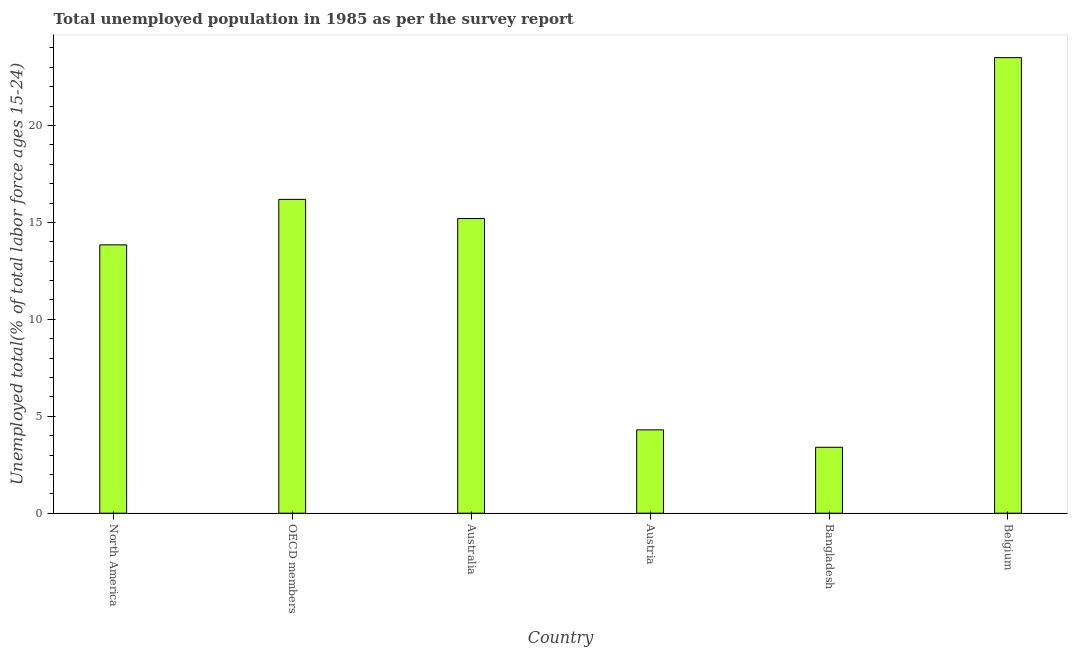Does the graph contain any zero values?
Provide a succinct answer. No. Does the graph contain grids?
Keep it short and to the point. No. What is the title of the graph?
Your answer should be very brief. Total unemployed population in 1985 as per the survey report. What is the label or title of the X-axis?
Your response must be concise. Country. What is the label or title of the Y-axis?
Your answer should be very brief. Unemployed total(% of total labor force ages 15-24). What is the unemployed youth in Bangladesh?
Offer a terse response. 3.4. Across all countries, what is the maximum unemployed youth?
Keep it short and to the point. 23.5. Across all countries, what is the minimum unemployed youth?
Your answer should be very brief. 3.4. In which country was the unemployed youth maximum?
Make the answer very short. Belgium. What is the sum of the unemployed youth?
Give a very brief answer. 76.43. What is the difference between the unemployed youth in Austria and Belgium?
Provide a short and direct response. -19.2. What is the average unemployed youth per country?
Keep it short and to the point. 12.74. What is the median unemployed youth?
Provide a short and direct response. 14.52. In how many countries, is the unemployed youth greater than 4 %?
Your response must be concise. 5. What is the ratio of the unemployed youth in Australia to that in Belgium?
Keep it short and to the point. 0.65. Is the unemployed youth in Austria less than that in OECD members?
Offer a very short reply. Yes. What is the difference between the highest and the second highest unemployed youth?
Provide a short and direct response. 7.31. What is the difference between the highest and the lowest unemployed youth?
Your answer should be compact. 20.1. In how many countries, is the unemployed youth greater than the average unemployed youth taken over all countries?
Your answer should be very brief. 4. How many bars are there?
Your answer should be very brief. 6. Are all the bars in the graph horizontal?
Provide a short and direct response. No. What is the difference between two consecutive major ticks on the Y-axis?
Make the answer very short. 5. What is the Unemployed total(% of total labor force ages 15-24) in North America?
Ensure brevity in your answer.  13.84. What is the Unemployed total(% of total labor force ages 15-24) in OECD members?
Your answer should be compact. 16.19. What is the Unemployed total(% of total labor force ages 15-24) of Australia?
Offer a very short reply. 15.2. What is the Unemployed total(% of total labor force ages 15-24) of Austria?
Offer a very short reply. 4.3. What is the Unemployed total(% of total labor force ages 15-24) of Bangladesh?
Give a very brief answer. 3.4. What is the difference between the Unemployed total(% of total labor force ages 15-24) in North America and OECD members?
Give a very brief answer. -2.35. What is the difference between the Unemployed total(% of total labor force ages 15-24) in North America and Australia?
Make the answer very short. -1.36. What is the difference between the Unemployed total(% of total labor force ages 15-24) in North America and Austria?
Give a very brief answer. 9.54. What is the difference between the Unemployed total(% of total labor force ages 15-24) in North America and Bangladesh?
Provide a short and direct response. 10.44. What is the difference between the Unemployed total(% of total labor force ages 15-24) in North America and Belgium?
Offer a terse response. -9.66. What is the difference between the Unemployed total(% of total labor force ages 15-24) in OECD members and Australia?
Provide a succinct answer. 0.99. What is the difference between the Unemployed total(% of total labor force ages 15-24) in OECD members and Austria?
Keep it short and to the point. 11.89. What is the difference between the Unemployed total(% of total labor force ages 15-24) in OECD members and Bangladesh?
Your answer should be very brief. 12.79. What is the difference between the Unemployed total(% of total labor force ages 15-24) in OECD members and Belgium?
Your response must be concise. -7.31. What is the difference between the Unemployed total(% of total labor force ages 15-24) in Australia and Austria?
Offer a very short reply. 10.9. What is the difference between the Unemployed total(% of total labor force ages 15-24) in Australia and Bangladesh?
Offer a very short reply. 11.8. What is the difference between the Unemployed total(% of total labor force ages 15-24) in Australia and Belgium?
Offer a very short reply. -8.3. What is the difference between the Unemployed total(% of total labor force ages 15-24) in Austria and Belgium?
Your response must be concise. -19.2. What is the difference between the Unemployed total(% of total labor force ages 15-24) in Bangladesh and Belgium?
Your answer should be very brief. -20.1. What is the ratio of the Unemployed total(% of total labor force ages 15-24) in North America to that in OECD members?
Your response must be concise. 0.85. What is the ratio of the Unemployed total(% of total labor force ages 15-24) in North America to that in Australia?
Provide a short and direct response. 0.91. What is the ratio of the Unemployed total(% of total labor force ages 15-24) in North America to that in Austria?
Provide a succinct answer. 3.22. What is the ratio of the Unemployed total(% of total labor force ages 15-24) in North America to that in Bangladesh?
Ensure brevity in your answer.  4.07. What is the ratio of the Unemployed total(% of total labor force ages 15-24) in North America to that in Belgium?
Keep it short and to the point. 0.59. What is the ratio of the Unemployed total(% of total labor force ages 15-24) in OECD members to that in Australia?
Offer a terse response. 1.06. What is the ratio of the Unemployed total(% of total labor force ages 15-24) in OECD members to that in Austria?
Provide a succinct answer. 3.77. What is the ratio of the Unemployed total(% of total labor force ages 15-24) in OECD members to that in Bangladesh?
Offer a very short reply. 4.76. What is the ratio of the Unemployed total(% of total labor force ages 15-24) in OECD members to that in Belgium?
Keep it short and to the point. 0.69. What is the ratio of the Unemployed total(% of total labor force ages 15-24) in Australia to that in Austria?
Make the answer very short. 3.54. What is the ratio of the Unemployed total(% of total labor force ages 15-24) in Australia to that in Bangladesh?
Your response must be concise. 4.47. What is the ratio of the Unemployed total(% of total labor force ages 15-24) in Australia to that in Belgium?
Make the answer very short. 0.65. What is the ratio of the Unemployed total(% of total labor force ages 15-24) in Austria to that in Bangladesh?
Your response must be concise. 1.26. What is the ratio of the Unemployed total(% of total labor force ages 15-24) in Austria to that in Belgium?
Your answer should be very brief. 0.18. What is the ratio of the Unemployed total(% of total labor force ages 15-24) in Bangladesh to that in Belgium?
Your response must be concise. 0.14. 